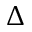<formula> <loc_0><loc_0><loc_500><loc_500>\Delta</formula> 